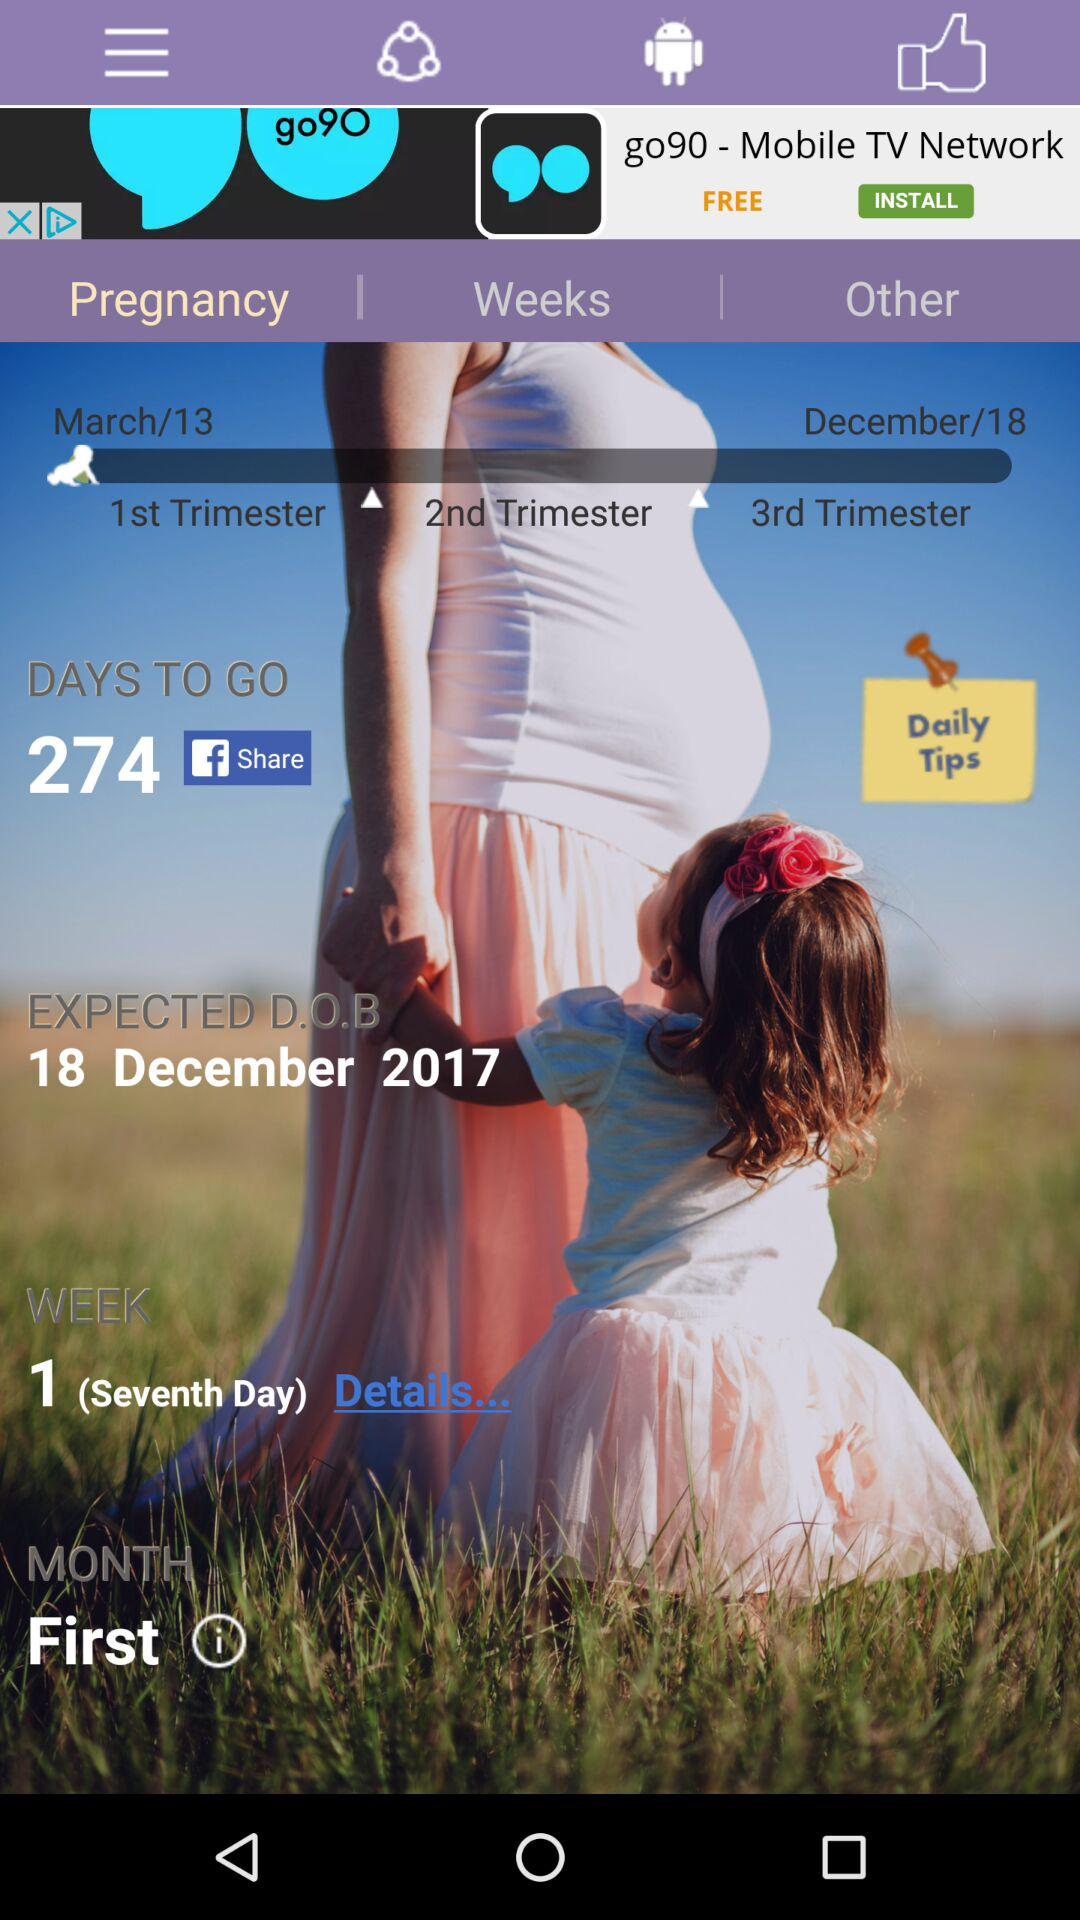What is the expected date of birth of the baby? The expected date of birth of the baby is December 18, 2017. 